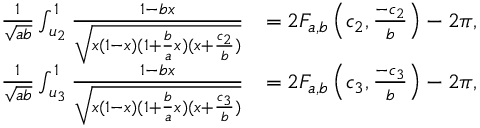Convert formula to latex. <formula><loc_0><loc_0><loc_500><loc_500>\begin{array} { r l } { \frac { 1 } { \sqrt { a b } } \int _ { u _ { 2 } } ^ { 1 } \frac { 1 - b x } { \sqrt { x ( 1 - x ) ( 1 + \frac { b } { a } x ) ( x + \frac { c _ { 2 } } { b } ) } } } & { = 2 F _ { a , b } \left ( c _ { 2 } , \frac { - c _ { 2 } } { b } \right ) - 2 \pi , } \\ { \frac { 1 } { \sqrt { a b } } \int _ { u _ { 3 } } ^ { 1 } \frac { 1 - b x } { \sqrt { x ( 1 - x ) ( 1 + \frac { b } { a } x ) ( x + \frac { c _ { 3 } } { b } ) } } } & { = 2 F _ { a , b } \left ( c _ { 3 } , \frac { - c _ { 3 } } { b } \right ) - 2 \pi , } \end{array}</formula> 